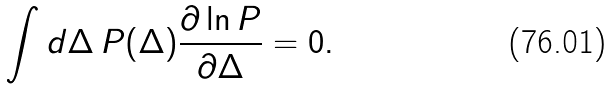Convert formula to latex. <formula><loc_0><loc_0><loc_500><loc_500>\int d \Delta \, P ( \Delta ) \frac { \partial \ln P } { \partial \Delta } = 0 .</formula> 